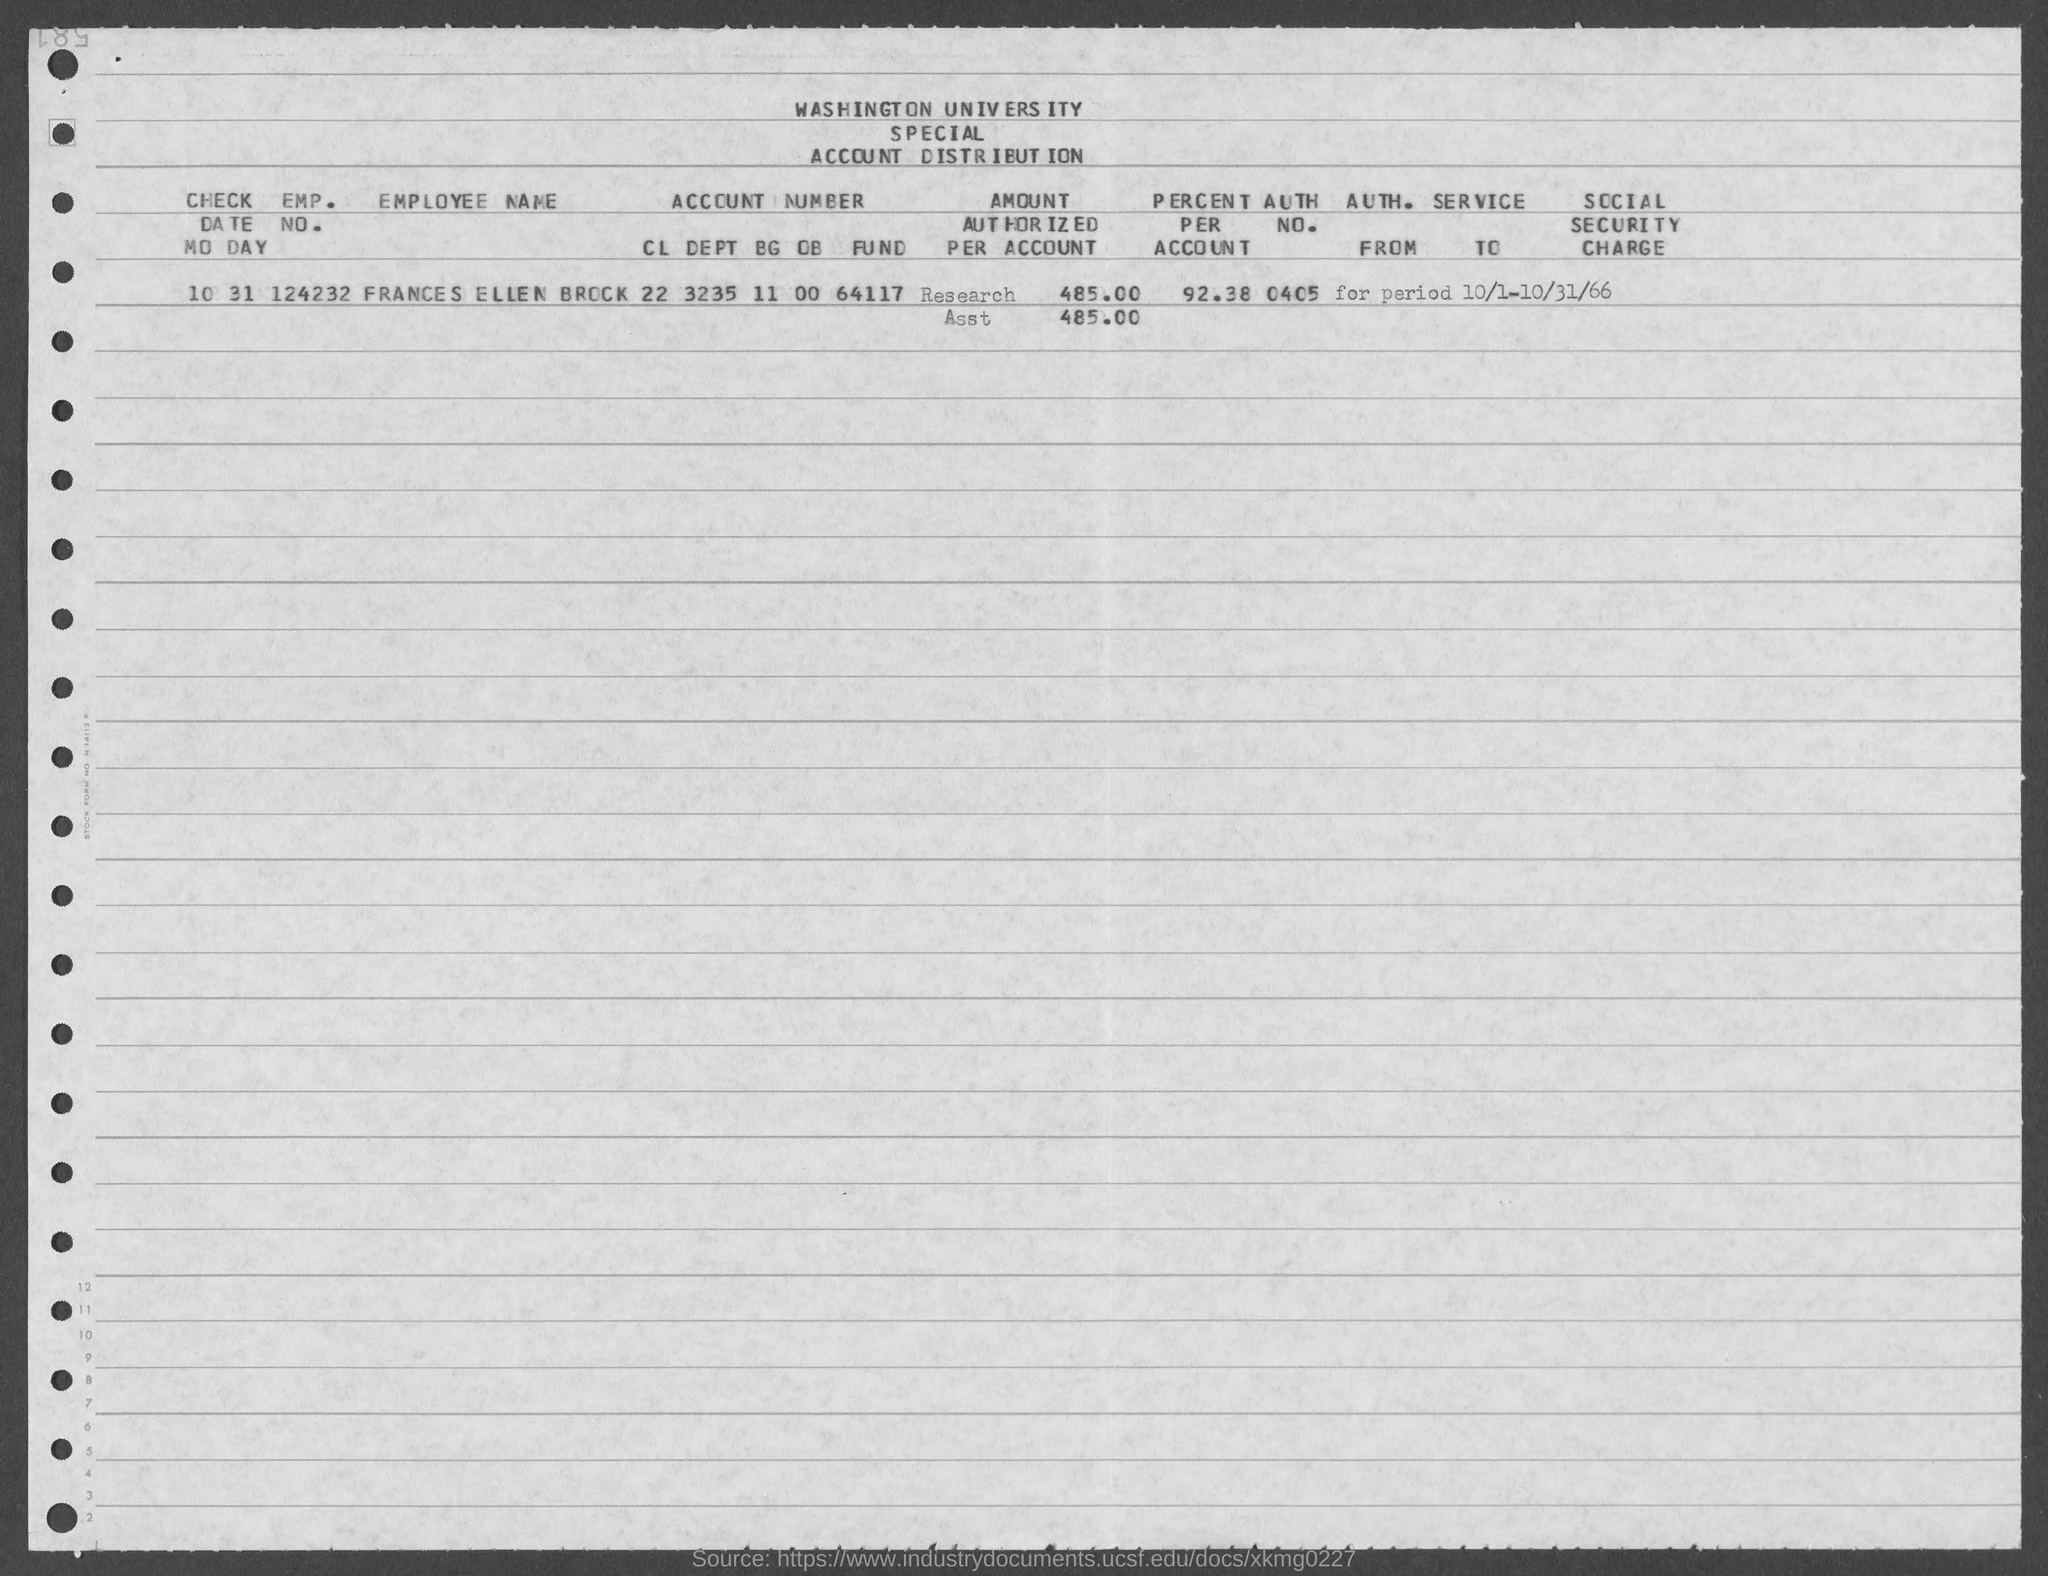What is the emp. no. of frances ellen brock ?
Make the answer very short. 124232. What is the percent per account of frances ellen brock ?
Offer a very short reply. 92.38%. What is the auth no. of frances ellen brock ?
Give a very brief answer. 0405. 